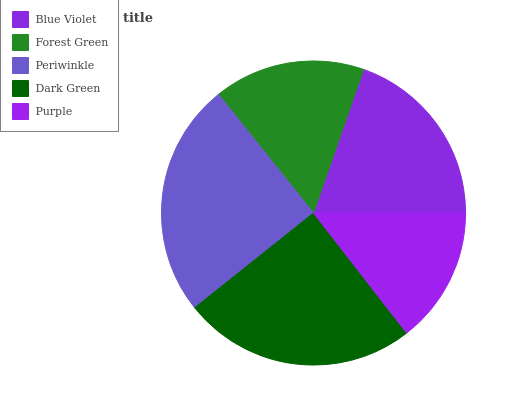Is Purple the minimum?
Answer yes or no. Yes. Is Periwinkle the maximum?
Answer yes or no. Yes. Is Forest Green the minimum?
Answer yes or no. No. Is Forest Green the maximum?
Answer yes or no. No. Is Blue Violet greater than Forest Green?
Answer yes or no. Yes. Is Forest Green less than Blue Violet?
Answer yes or no. Yes. Is Forest Green greater than Blue Violet?
Answer yes or no. No. Is Blue Violet less than Forest Green?
Answer yes or no. No. Is Blue Violet the high median?
Answer yes or no. Yes. Is Blue Violet the low median?
Answer yes or no. Yes. Is Purple the high median?
Answer yes or no. No. Is Dark Green the low median?
Answer yes or no. No. 